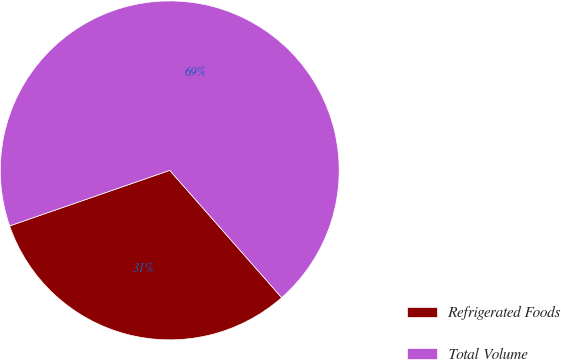Convert chart. <chart><loc_0><loc_0><loc_500><loc_500><pie_chart><fcel>Refrigerated Foods<fcel>Total Volume<nl><fcel>31.17%<fcel>68.83%<nl></chart> 